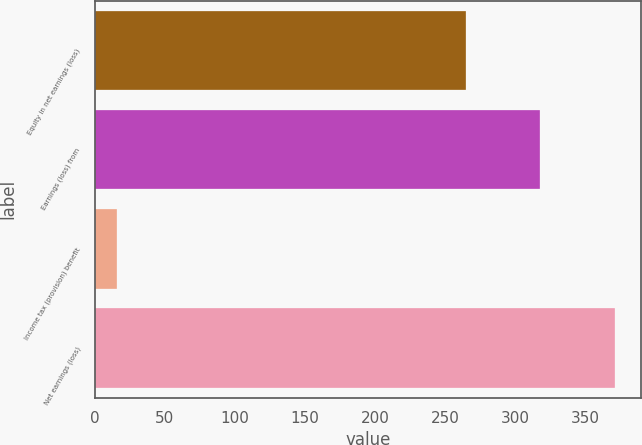<chart> <loc_0><loc_0><loc_500><loc_500><bar_chart><fcel>Equity in net earnings (loss)<fcel>Earnings (loss) from<fcel>Income tax (provision) benefit<fcel>Net earnings (loss)<nl><fcel>265<fcel>318<fcel>16<fcel>371<nl></chart> 